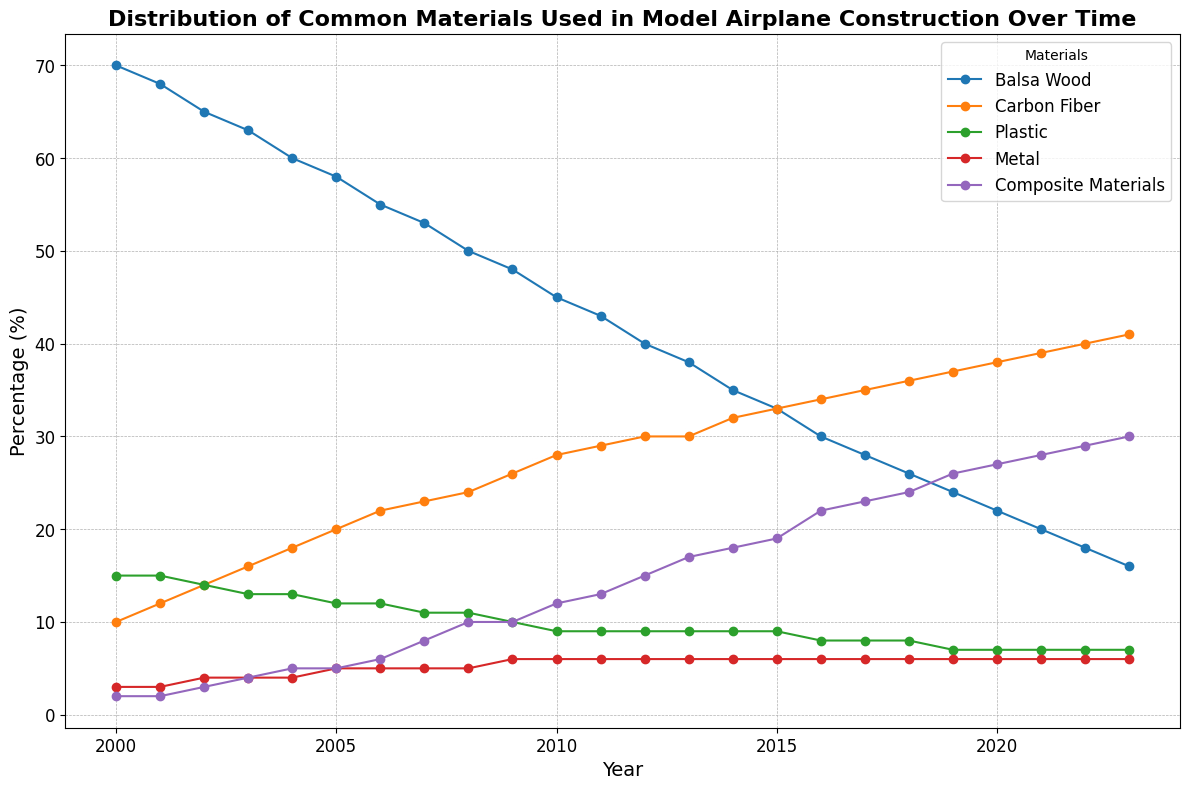What is the trend for the usage of Balsa Wood from 2000 to 2023? To determine the trend, observe the plotted line for Balsa Wood. We see it begins at 70% in 2000 and steadily decreases over the years, ending at 16% in 2023. This indicates a downward trend in the usage of Balsa Wood.
Answer: The usage of Balsa Wood has a downward trend Which material showed the most significant increase in usage over the years? To answer this, compare the initial and final values of each material's line. Balsa Wood decreased, while Carbon Fiber, Plastic, and Metal had varying but smaller changes. Composite Materials increased from 2% in 2000 to 30% in 2023, which is the largest change.
Answer: Composite Materials In which year did Carbon Fiber's usage surpass Balsa Wood's usage? Observe the intersecting point of the lines representing Carbon Fiber and Balsa Wood. Carbon Fiber surpasses Balsa Wood in 2015 when Carbon Fiber reaches 33% and Balsa Wood drops to 33%.
Answer: 2015 How does the availability of Plastic change over time? Examine the plotted line for Plastic. It starts at 15% in 2000, fluctuates slightly, and stabilizes around 7% from 2010 onwards.
Answer: The availability of Plastic decreases and stabilizes What is the combined percentage of Metal and Composite Materials in 2023? Add the values for Metal (6%) and Composite Materials (30%) for the year 2023.
Answer: 36% During which period did Balsa Wood and Composite Materials show the most distinct usage trend? Comparing each material's line, Balsa Wood steadily decreases, while Composite Materials steadily increase. This distinct opposite trend is most significant around 2007-2023.
Answer: 2007-2023 Which year did Composite Materials reach 15%? Observe the plotted line for Composite Materials and find the point where it intersects 15%. This occurs in 2012.
Answer: 2012 Between 2000 and 2010, which material had the most stable availability? Examine the flatness of each line. Metal's line is consistently stable around 3-6%, making it the most stable material in this period.
Answer: Metal By how much did the usage of Carbon Fiber increase from 2000 to 2023? Subtract the percentage of 2000 (10%) from the percentage in 2023 (41%). Calculating the difference: 41% - 10% = 31%.
Answer: 31% What is the average percentage of Plastic usage from 2000 to 2023? Sum the yearly percentages for Plastic and divide by the number of years (24). Performing the calculation: (15 + 15 + 14 + 13 + 13 + 12 + 12 + 11 + 11 + 10 + 9 + 9 + 9 + 9 + 9 + 9 + 8 + 8 + 8 + 7 + 7 + 7 + 7 + 7) / 24 = 10.25%.
Answer: 10.25% 